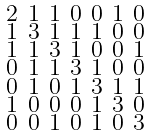Convert formula to latex. <formula><loc_0><loc_0><loc_500><loc_500>\begin{smallmatrix} 2 & 1 & 1 & 0 & 0 & 1 & 0 \\ 1 & 3 & 1 & 1 & 1 & 0 & 0 \\ 1 & 1 & 3 & 1 & 0 & 0 & 1 \\ 0 & 1 & 1 & 3 & 1 & 0 & 0 \\ 0 & 1 & 0 & 1 & 3 & 1 & 1 \\ 1 & 0 & 0 & 0 & 1 & 3 & 0 \\ 0 & 0 & 1 & 0 & 1 & 0 & 3 \end{smallmatrix}</formula> 